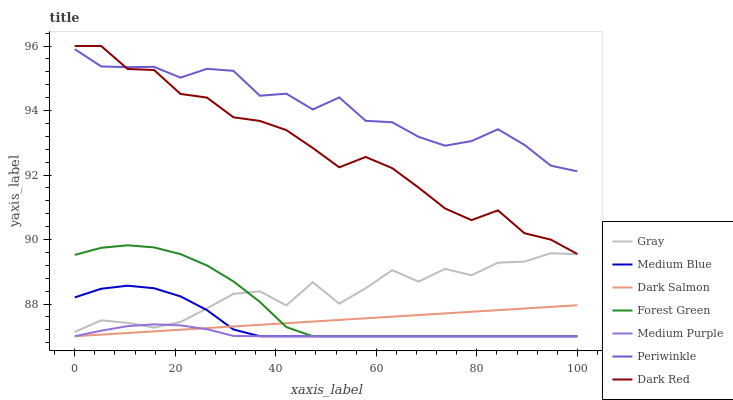Does Medium Purple have the minimum area under the curve?
Answer yes or no. Yes. Does Periwinkle have the maximum area under the curve?
Answer yes or no. Yes. Does Dark Red have the minimum area under the curve?
Answer yes or no. No. Does Dark Red have the maximum area under the curve?
Answer yes or no. No. Is Dark Salmon the smoothest?
Answer yes or no. Yes. Is Gray the roughest?
Answer yes or no. Yes. Is Dark Red the smoothest?
Answer yes or no. No. Is Dark Red the roughest?
Answer yes or no. No. Does Medium Blue have the lowest value?
Answer yes or no. Yes. Does Dark Red have the lowest value?
Answer yes or no. No. Does Dark Red have the highest value?
Answer yes or no. Yes. Does Medium Blue have the highest value?
Answer yes or no. No. Is Dark Salmon less than Gray?
Answer yes or no. Yes. Is Periwinkle greater than Gray?
Answer yes or no. Yes. Does Medium Blue intersect Forest Green?
Answer yes or no. Yes. Is Medium Blue less than Forest Green?
Answer yes or no. No. Is Medium Blue greater than Forest Green?
Answer yes or no. No. Does Dark Salmon intersect Gray?
Answer yes or no. No. 